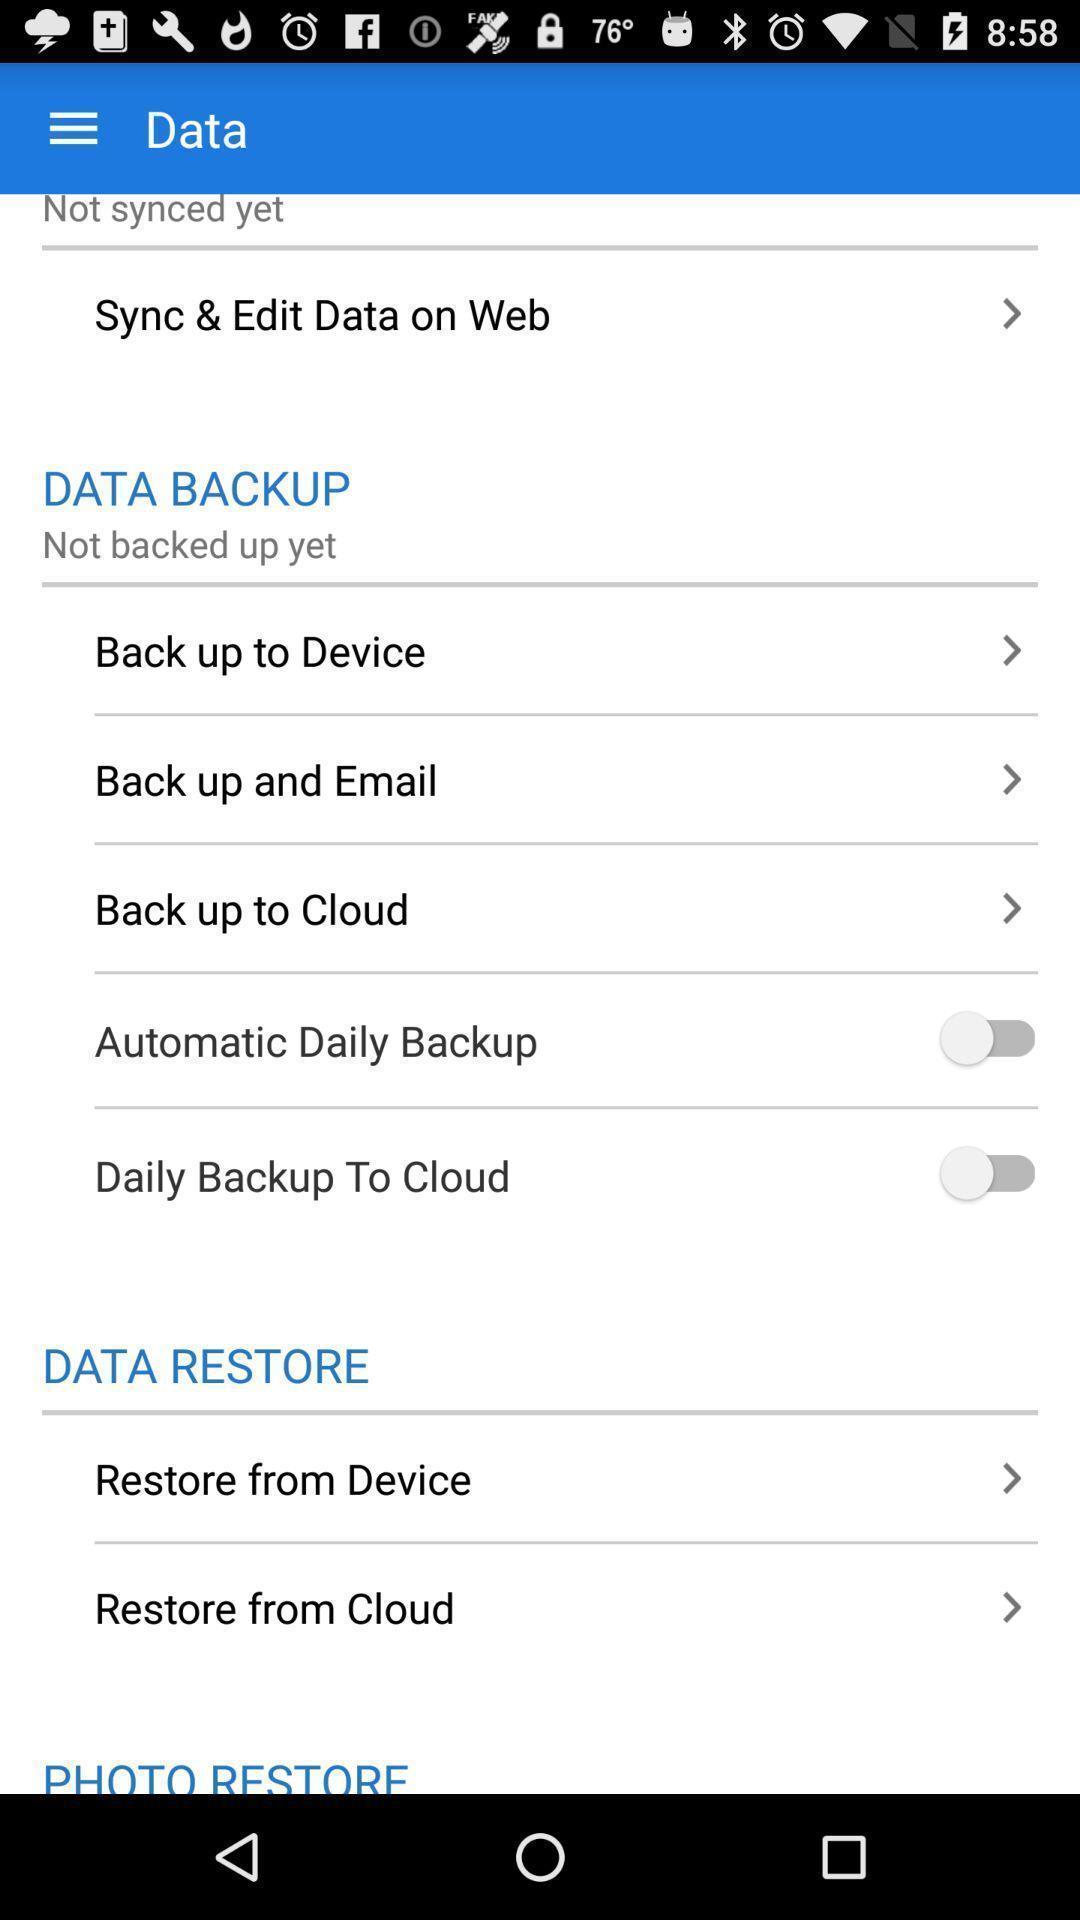Describe the key features of this screenshot. Screen shows several data options. 